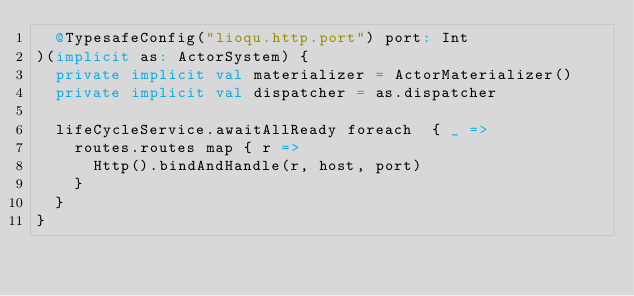<code> <loc_0><loc_0><loc_500><loc_500><_Scala_>  @TypesafeConfig("lioqu.http.port") port: Int
)(implicit as: ActorSystem) {
  private implicit val materializer = ActorMaterializer()
  private implicit val dispatcher = as.dispatcher

  lifeCycleService.awaitAllReady foreach  { _ =>
    routes.routes map { r =>
      Http().bindAndHandle(r, host, port)
    }
  }
}
</code> 